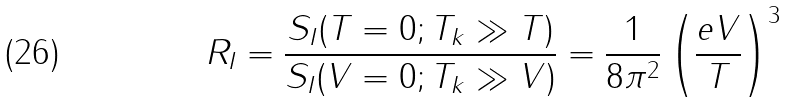<formula> <loc_0><loc_0><loc_500><loc_500>R _ { I } = { \frac { S _ { I } ( T = 0 ; T _ { k } \gg T ) } { S _ { I } ( V = 0 ; T _ { k } \gg V ) } } = \frac { 1 } { 8 { \pi ^ { 2 } } } \left ( \frac { e V } { T } \right ) ^ { 3 }</formula> 